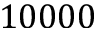<formula> <loc_0><loc_0><loc_500><loc_500>1 0 0 0 0</formula> 